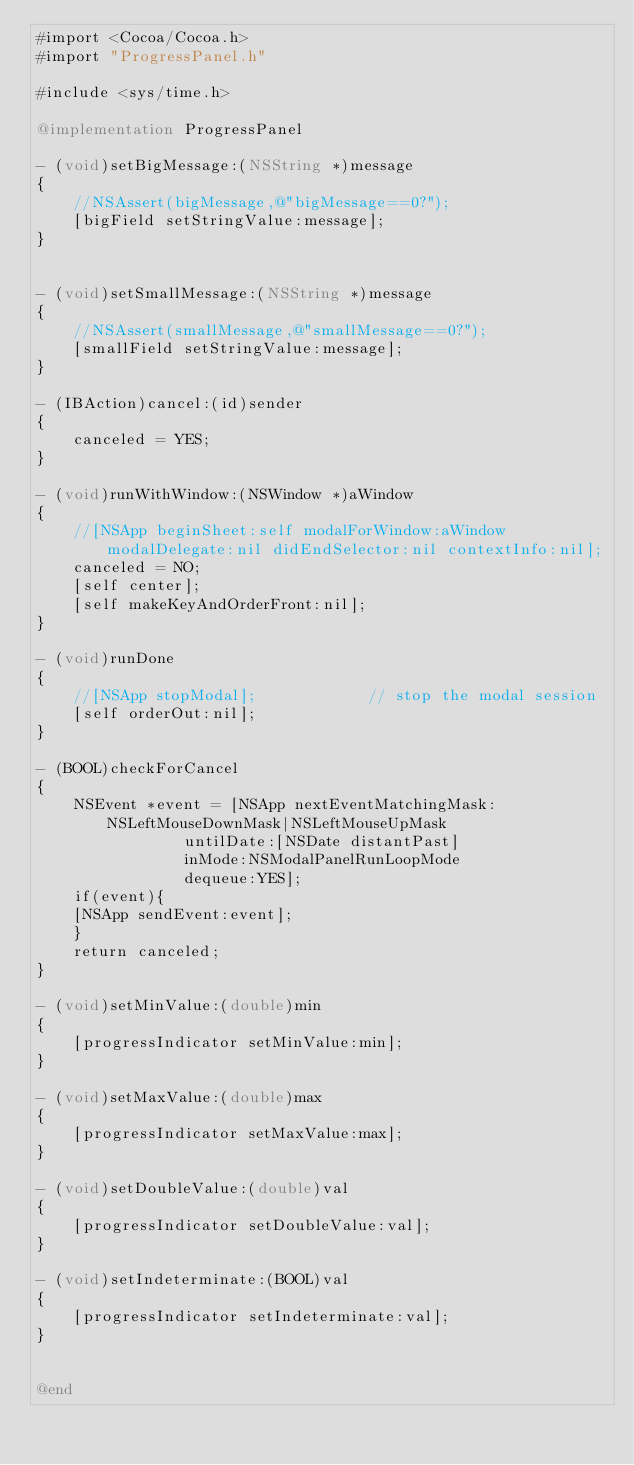<code> <loc_0><loc_0><loc_500><loc_500><_ObjectiveC_>#import <Cocoa/Cocoa.h>
#import "ProgressPanel.h"

#include <sys/time.h>

@implementation ProgressPanel

- (void)setBigMessage:(NSString *)message
{
    //NSAssert(bigMessage,@"bigMessage==0?");
    [bigField setStringValue:message];
}


- (void)setSmallMessage:(NSString *)message
{
    //NSAssert(smallMessage,@"smallMessage==0?");
    [smallField setStringValue:message];
}

- (IBAction)cancel:(id)sender
{
    canceled = YES;
}

- (void)runWithWindow:(NSWindow *)aWindow
{
    //[NSApp beginSheet:self modalForWindow:aWindow modalDelegate:nil didEndSelector:nil contextInfo:nil];
    canceled = NO;
    [self center];
    [self makeKeyAndOrderFront:nil];
}

- (void)runDone
{
    //[NSApp stopModal];			// stop the modal session
    [self orderOut:nil];
}

- (BOOL)checkForCancel
{
    NSEvent *event = [NSApp nextEventMatchingMask:NSLeftMouseDownMask|NSLeftMouseUpMask
			    untilDate:[NSDate distantPast]
			    inMode:NSModalPanelRunLoopMode
			    dequeue:YES];
    if(event){
	[NSApp sendEvent:event];
    }
    return canceled;
}

- (void)setMinValue:(double)min
{
    [progressIndicator setMinValue:min];
}

- (void)setMaxValue:(double)max
{
    [progressIndicator setMaxValue:max];
}

- (void)setDoubleValue:(double)val
{
    [progressIndicator setDoubleValue:val];
}

- (void)setIndeterminate:(BOOL)val
{
    [progressIndicator setIndeterminate:val];
}


@end
</code> 